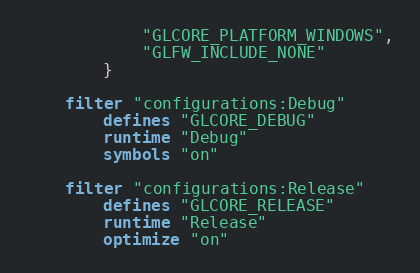Convert code to text. <code><loc_0><loc_0><loc_500><loc_500><_Lua_>			"GLCORE_PLATFORM_WINDOWS",
			"GLFW_INCLUDE_NONE"
		}

	filter "configurations:Debug"
		defines "GLCORE_DEBUG"
		runtime "Debug"
		symbols "on"

	filter "configurations:Release"
		defines "GLCORE_RELEASE"
		runtime "Release"
		optimize "on"</code> 